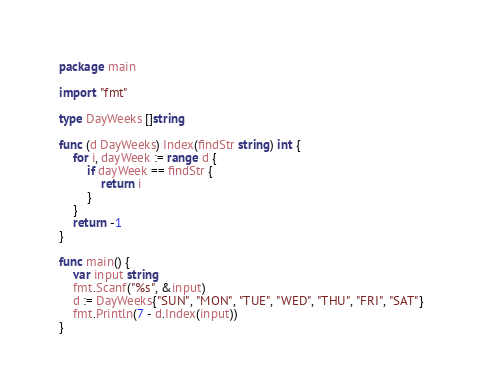<code> <loc_0><loc_0><loc_500><loc_500><_Go_>package main

import "fmt"

type DayWeeks []string

func (d DayWeeks) Index(findStr string) int {
	for i, dayWeek := range d {
		if dayWeek == findStr {
			return i
		}
	}
	return -1
}

func main() {
	var input string
	fmt.Scanf("%s", &input)
	d := DayWeeks{"SUN", "MON", "TUE", "WED", "THU", "FRI", "SAT"}
	fmt.Println(7 - d.Index(input))
}</code> 